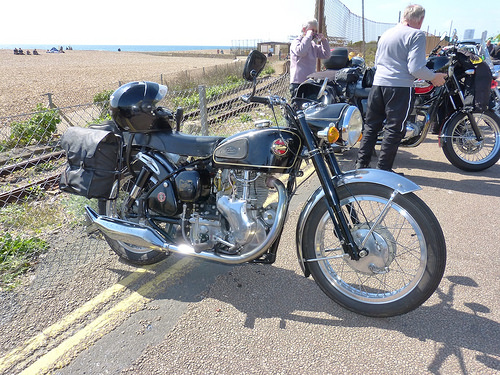<image>
Is there a fence behind the bike? Yes. From this viewpoint, the fence is positioned behind the bike, with the bike partially or fully occluding the fence. Where is the bike in relation to the sea? Is it next to the sea? No. The bike is not positioned next to the sea. They are located in different areas of the scene. 